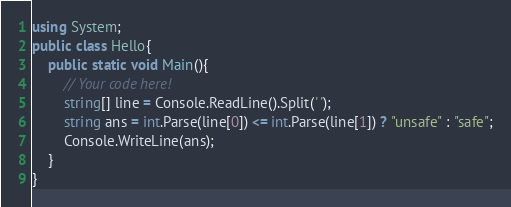Convert code to text. <code><loc_0><loc_0><loc_500><loc_500><_C#_>using System;
public class Hello{
    public static void Main(){
        // Your code here!
        string[] line = Console.ReadLine().Split(' ');
        string ans = int.Parse(line[0]) <= int.Parse(line[1]) ? "unsafe" : "safe";
        Console.WriteLine(ans);
    }
}
</code> 